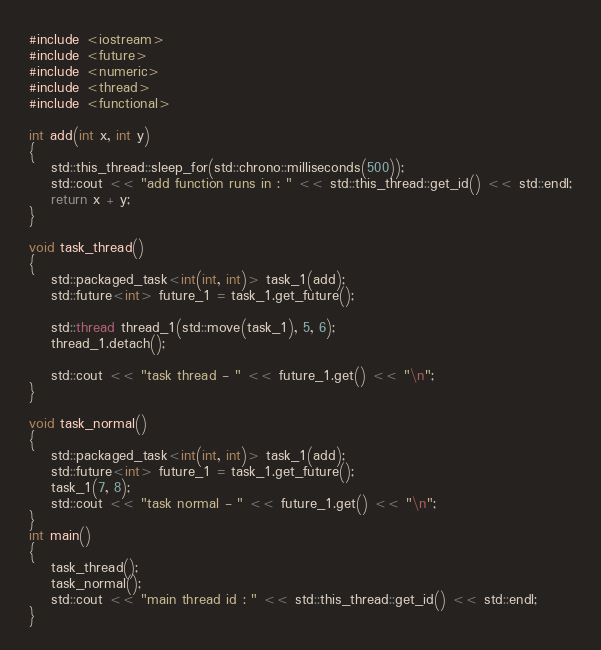<code> <loc_0><loc_0><loc_500><loc_500><_C++_>#include <iostream>
#include <future>
#include <numeric>
#include <thread>
#include <functional>

int add(int x, int y)
{
	std::this_thread::sleep_for(std::chrono::milliseconds(500));
	std::cout << "add function runs in : " << std::this_thread::get_id() << std::endl;
	return x + y;
}

void task_thread()
{
	std::packaged_task<int(int, int)> task_1(add);
	std::future<int> future_1 = task_1.get_future();

	std::thread thread_1(std::move(task_1), 5, 6);
	thread_1.detach();

	std::cout << "task thread - " << future_1.get() << "\n";
}

void task_normal()
{
	std::packaged_task<int(int, int)> task_1(add);
	std::future<int> future_1 = task_1.get_future();
	task_1(7, 8);
	std::cout << "task normal - " << future_1.get() << "\n";
}
int main()
{
	task_thread();
	task_normal();
	std::cout << "main thread id : " << std::this_thread::get_id() << std::endl;
}</code> 